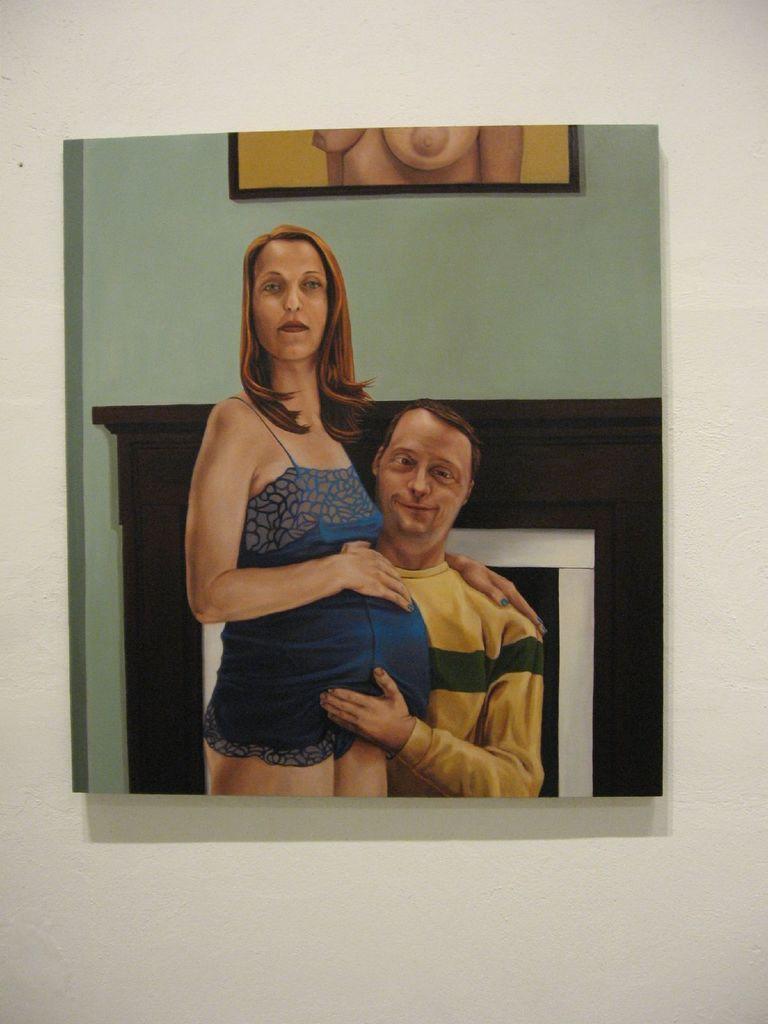Can you describe this image briefly? In this image I can see two persons. The person at right wearing yellow shirt and the person at left wearing blue dress, at the back I can see a frame attached to the wall and the wall is in green color. 